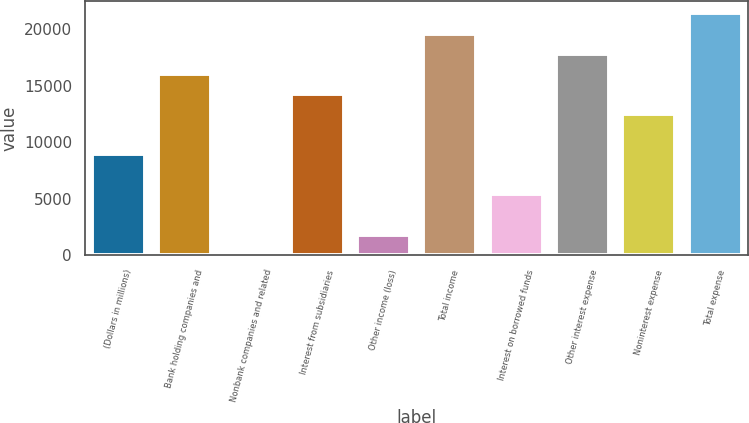<chart> <loc_0><loc_0><loc_500><loc_500><bar_chart><fcel>(Dollars in millions)<fcel>Bank holding companies and<fcel>Nonbank companies and related<fcel>Interest from subsidiaries<fcel>Other income (loss)<fcel>Total income<fcel>Interest on borrowed funds<fcel>Other interest expense<fcel>Noninterest expense<fcel>Total expense<nl><fcel>8949.5<fcel>16047.5<fcel>77<fcel>14273<fcel>1851.5<fcel>19596.5<fcel>5400.5<fcel>17822<fcel>12498.5<fcel>21371<nl></chart> 